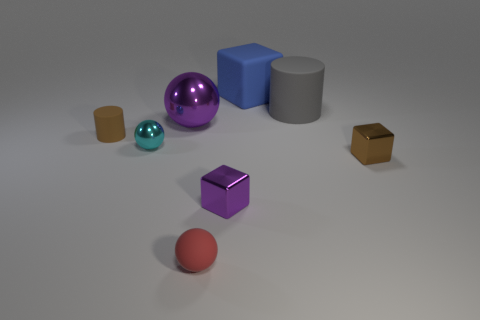There is a tiny shiny thing that is the same color as the big shiny ball; what shape is it?
Make the answer very short. Cube. Is the material of the small red sphere the same as the brown thing behind the brown block?
Offer a terse response. Yes. Are there any other big red metallic objects that have the same shape as the big metallic thing?
Your answer should be very brief. No. What material is the purple ball that is the same size as the gray thing?
Offer a terse response. Metal. There is a shiny cube to the left of the large cube; what size is it?
Your response must be concise. Small. There is a shiny sphere to the left of the purple metallic sphere; does it have the same size as the rubber thing that is to the left of the purple sphere?
Make the answer very short. Yes. What number of big gray cylinders are made of the same material as the tiny brown cylinder?
Your answer should be very brief. 1. The big metal thing has what color?
Give a very brief answer. Purple. Are there any big blue blocks in front of the brown metallic thing?
Give a very brief answer. No. Is the big sphere the same color as the big rubber cylinder?
Your answer should be very brief. No. 